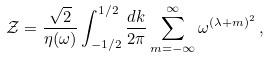<formula> <loc_0><loc_0><loc_500><loc_500>\mathcal { Z } = \frac { \sqrt { 2 } } { \eta ( \omega ) } \int _ { - 1 / 2 } ^ { 1 / 2 } \frac { d k } { 2 \pi } \sum _ { m = - \infty } ^ { \infty } \omega ^ { ( \lambda + m ) ^ { 2 } } \, ,</formula> 